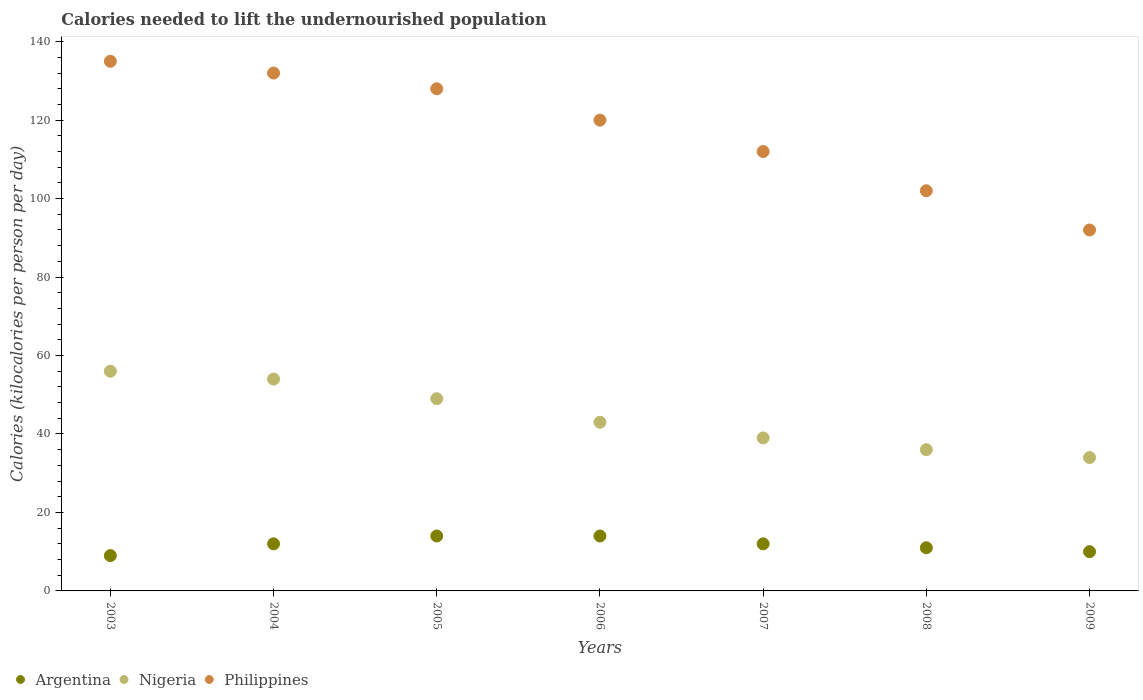What is the total calories needed to lift the undernourished population in Argentina in 2007?
Offer a terse response. 12. Across all years, what is the maximum total calories needed to lift the undernourished population in Philippines?
Provide a succinct answer. 135. Across all years, what is the minimum total calories needed to lift the undernourished population in Philippines?
Provide a succinct answer. 92. In which year was the total calories needed to lift the undernourished population in Philippines minimum?
Your response must be concise. 2009. What is the total total calories needed to lift the undernourished population in Philippines in the graph?
Your response must be concise. 821. What is the difference between the total calories needed to lift the undernourished population in Philippines in 2003 and that in 2005?
Your answer should be compact. 7. What is the difference between the total calories needed to lift the undernourished population in Philippines in 2004 and the total calories needed to lift the undernourished population in Nigeria in 2009?
Provide a short and direct response. 98. What is the average total calories needed to lift the undernourished population in Philippines per year?
Offer a terse response. 117.29. In the year 2006, what is the difference between the total calories needed to lift the undernourished population in Argentina and total calories needed to lift the undernourished population in Philippines?
Your response must be concise. -106. What is the ratio of the total calories needed to lift the undernourished population in Nigeria in 2003 to that in 2005?
Offer a terse response. 1.14. Is the total calories needed to lift the undernourished population in Argentina in 2005 less than that in 2007?
Your response must be concise. No. Is the difference between the total calories needed to lift the undernourished population in Argentina in 2006 and 2007 greater than the difference between the total calories needed to lift the undernourished population in Philippines in 2006 and 2007?
Ensure brevity in your answer.  No. What is the difference between the highest and the lowest total calories needed to lift the undernourished population in Philippines?
Give a very brief answer. 43. Is the total calories needed to lift the undernourished population in Argentina strictly greater than the total calories needed to lift the undernourished population in Nigeria over the years?
Make the answer very short. No. What is the difference between two consecutive major ticks on the Y-axis?
Keep it short and to the point. 20. How many legend labels are there?
Offer a terse response. 3. How are the legend labels stacked?
Make the answer very short. Horizontal. What is the title of the graph?
Keep it short and to the point. Calories needed to lift the undernourished population. Does "France" appear as one of the legend labels in the graph?
Make the answer very short. No. What is the label or title of the X-axis?
Your answer should be very brief. Years. What is the label or title of the Y-axis?
Your response must be concise. Calories (kilocalories per person per day). What is the Calories (kilocalories per person per day) in Philippines in 2003?
Provide a succinct answer. 135. What is the Calories (kilocalories per person per day) of Nigeria in 2004?
Your answer should be very brief. 54. What is the Calories (kilocalories per person per day) in Philippines in 2004?
Provide a succinct answer. 132. What is the Calories (kilocalories per person per day) of Philippines in 2005?
Ensure brevity in your answer.  128. What is the Calories (kilocalories per person per day) of Argentina in 2006?
Your answer should be very brief. 14. What is the Calories (kilocalories per person per day) in Nigeria in 2006?
Your answer should be very brief. 43. What is the Calories (kilocalories per person per day) in Philippines in 2006?
Provide a succinct answer. 120. What is the Calories (kilocalories per person per day) in Nigeria in 2007?
Your answer should be compact. 39. What is the Calories (kilocalories per person per day) in Philippines in 2007?
Your answer should be very brief. 112. What is the Calories (kilocalories per person per day) of Argentina in 2008?
Offer a terse response. 11. What is the Calories (kilocalories per person per day) of Nigeria in 2008?
Provide a short and direct response. 36. What is the Calories (kilocalories per person per day) in Philippines in 2008?
Ensure brevity in your answer.  102. What is the Calories (kilocalories per person per day) in Philippines in 2009?
Make the answer very short. 92. Across all years, what is the maximum Calories (kilocalories per person per day) of Argentina?
Offer a very short reply. 14. Across all years, what is the maximum Calories (kilocalories per person per day) of Nigeria?
Your answer should be very brief. 56. Across all years, what is the maximum Calories (kilocalories per person per day) of Philippines?
Offer a terse response. 135. Across all years, what is the minimum Calories (kilocalories per person per day) in Nigeria?
Make the answer very short. 34. Across all years, what is the minimum Calories (kilocalories per person per day) in Philippines?
Ensure brevity in your answer.  92. What is the total Calories (kilocalories per person per day) of Nigeria in the graph?
Make the answer very short. 311. What is the total Calories (kilocalories per person per day) of Philippines in the graph?
Offer a very short reply. 821. What is the difference between the Calories (kilocalories per person per day) of Argentina in 2003 and that in 2004?
Your response must be concise. -3. What is the difference between the Calories (kilocalories per person per day) in Philippines in 2003 and that in 2004?
Your response must be concise. 3. What is the difference between the Calories (kilocalories per person per day) in Argentina in 2003 and that in 2005?
Your response must be concise. -5. What is the difference between the Calories (kilocalories per person per day) of Philippines in 2003 and that in 2005?
Provide a short and direct response. 7. What is the difference between the Calories (kilocalories per person per day) of Philippines in 2003 and that in 2006?
Offer a terse response. 15. What is the difference between the Calories (kilocalories per person per day) of Nigeria in 2003 and that in 2008?
Your answer should be compact. 20. What is the difference between the Calories (kilocalories per person per day) of Philippines in 2003 and that in 2008?
Provide a short and direct response. 33. What is the difference between the Calories (kilocalories per person per day) of Nigeria in 2003 and that in 2009?
Offer a very short reply. 22. What is the difference between the Calories (kilocalories per person per day) of Philippines in 2003 and that in 2009?
Give a very brief answer. 43. What is the difference between the Calories (kilocalories per person per day) in Nigeria in 2004 and that in 2005?
Give a very brief answer. 5. What is the difference between the Calories (kilocalories per person per day) of Nigeria in 2004 and that in 2006?
Keep it short and to the point. 11. What is the difference between the Calories (kilocalories per person per day) of Philippines in 2004 and that in 2006?
Keep it short and to the point. 12. What is the difference between the Calories (kilocalories per person per day) of Argentina in 2004 and that in 2007?
Your answer should be very brief. 0. What is the difference between the Calories (kilocalories per person per day) of Philippines in 2004 and that in 2007?
Give a very brief answer. 20. What is the difference between the Calories (kilocalories per person per day) in Argentina in 2004 and that in 2008?
Ensure brevity in your answer.  1. What is the difference between the Calories (kilocalories per person per day) of Nigeria in 2004 and that in 2008?
Give a very brief answer. 18. What is the difference between the Calories (kilocalories per person per day) of Nigeria in 2004 and that in 2009?
Make the answer very short. 20. What is the difference between the Calories (kilocalories per person per day) in Argentina in 2005 and that in 2007?
Offer a very short reply. 2. What is the difference between the Calories (kilocalories per person per day) in Philippines in 2005 and that in 2007?
Ensure brevity in your answer.  16. What is the difference between the Calories (kilocalories per person per day) in Argentina in 2005 and that in 2009?
Your answer should be compact. 4. What is the difference between the Calories (kilocalories per person per day) of Nigeria in 2005 and that in 2009?
Your answer should be very brief. 15. What is the difference between the Calories (kilocalories per person per day) in Argentina in 2006 and that in 2007?
Your answer should be very brief. 2. What is the difference between the Calories (kilocalories per person per day) of Philippines in 2006 and that in 2008?
Provide a short and direct response. 18. What is the difference between the Calories (kilocalories per person per day) in Argentina in 2006 and that in 2009?
Offer a terse response. 4. What is the difference between the Calories (kilocalories per person per day) in Nigeria in 2006 and that in 2009?
Offer a very short reply. 9. What is the difference between the Calories (kilocalories per person per day) in Philippines in 2006 and that in 2009?
Provide a succinct answer. 28. What is the difference between the Calories (kilocalories per person per day) in Nigeria in 2007 and that in 2008?
Your answer should be compact. 3. What is the difference between the Calories (kilocalories per person per day) of Argentina in 2007 and that in 2009?
Your answer should be compact. 2. What is the difference between the Calories (kilocalories per person per day) of Nigeria in 2007 and that in 2009?
Give a very brief answer. 5. What is the difference between the Calories (kilocalories per person per day) in Argentina in 2003 and the Calories (kilocalories per person per day) in Nigeria in 2004?
Ensure brevity in your answer.  -45. What is the difference between the Calories (kilocalories per person per day) in Argentina in 2003 and the Calories (kilocalories per person per day) in Philippines in 2004?
Your answer should be compact. -123. What is the difference between the Calories (kilocalories per person per day) in Nigeria in 2003 and the Calories (kilocalories per person per day) in Philippines in 2004?
Provide a succinct answer. -76. What is the difference between the Calories (kilocalories per person per day) in Argentina in 2003 and the Calories (kilocalories per person per day) in Nigeria in 2005?
Provide a short and direct response. -40. What is the difference between the Calories (kilocalories per person per day) in Argentina in 2003 and the Calories (kilocalories per person per day) in Philippines in 2005?
Ensure brevity in your answer.  -119. What is the difference between the Calories (kilocalories per person per day) in Nigeria in 2003 and the Calories (kilocalories per person per day) in Philippines in 2005?
Ensure brevity in your answer.  -72. What is the difference between the Calories (kilocalories per person per day) of Argentina in 2003 and the Calories (kilocalories per person per day) of Nigeria in 2006?
Make the answer very short. -34. What is the difference between the Calories (kilocalories per person per day) of Argentina in 2003 and the Calories (kilocalories per person per day) of Philippines in 2006?
Provide a short and direct response. -111. What is the difference between the Calories (kilocalories per person per day) in Nigeria in 2003 and the Calories (kilocalories per person per day) in Philippines in 2006?
Offer a very short reply. -64. What is the difference between the Calories (kilocalories per person per day) in Argentina in 2003 and the Calories (kilocalories per person per day) in Nigeria in 2007?
Offer a terse response. -30. What is the difference between the Calories (kilocalories per person per day) of Argentina in 2003 and the Calories (kilocalories per person per day) of Philippines in 2007?
Your answer should be compact. -103. What is the difference between the Calories (kilocalories per person per day) in Nigeria in 2003 and the Calories (kilocalories per person per day) in Philippines in 2007?
Offer a terse response. -56. What is the difference between the Calories (kilocalories per person per day) of Argentina in 2003 and the Calories (kilocalories per person per day) of Philippines in 2008?
Keep it short and to the point. -93. What is the difference between the Calories (kilocalories per person per day) in Nigeria in 2003 and the Calories (kilocalories per person per day) in Philippines in 2008?
Provide a succinct answer. -46. What is the difference between the Calories (kilocalories per person per day) of Argentina in 2003 and the Calories (kilocalories per person per day) of Philippines in 2009?
Your response must be concise. -83. What is the difference between the Calories (kilocalories per person per day) in Nigeria in 2003 and the Calories (kilocalories per person per day) in Philippines in 2009?
Make the answer very short. -36. What is the difference between the Calories (kilocalories per person per day) in Argentina in 2004 and the Calories (kilocalories per person per day) in Nigeria in 2005?
Your response must be concise. -37. What is the difference between the Calories (kilocalories per person per day) of Argentina in 2004 and the Calories (kilocalories per person per day) of Philippines in 2005?
Keep it short and to the point. -116. What is the difference between the Calories (kilocalories per person per day) in Nigeria in 2004 and the Calories (kilocalories per person per day) in Philippines in 2005?
Your answer should be compact. -74. What is the difference between the Calories (kilocalories per person per day) of Argentina in 2004 and the Calories (kilocalories per person per day) of Nigeria in 2006?
Ensure brevity in your answer.  -31. What is the difference between the Calories (kilocalories per person per day) of Argentina in 2004 and the Calories (kilocalories per person per day) of Philippines in 2006?
Make the answer very short. -108. What is the difference between the Calories (kilocalories per person per day) in Nigeria in 2004 and the Calories (kilocalories per person per day) in Philippines in 2006?
Your answer should be very brief. -66. What is the difference between the Calories (kilocalories per person per day) in Argentina in 2004 and the Calories (kilocalories per person per day) in Nigeria in 2007?
Offer a terse response. -27. What is the difference between the Calories (kilocalories per person per day) in Argentina in 2004 and the Calories (kilocalories per person per day) in Philippines in 2007?
Your answer should be very brief. -100. What is the difference between the Calories (kilocalories per person per day) in Nigeria in 2004 and the Calories (kilocalories per person per day) in Philippines in 2007?
Keep it short and to the point. -58. What is the difference between the Calories (kilocalories per person per day) in Argentina in 2004 and the Calories (kilocalories per person per day) in Nigeria in 2008?
Offer a terse response. -24. What is the difference between the Calories (kilocalories per person per day) in Argentina in 2004 and the Calories (kilocalories per person per day) in Philippines in 2008?
Offer a terse response. -90. What is the difference between the Calories (kilocalories per person per day) of Nigeria in 2004 and the Calories (kilocalories per person per day) of Philippines in 2008?
Offer a terse response. -48. What is the difference between the Calories (kilocalories per person per day) in Argentina in 2004 and the Calories (kilocalories per person per day) in Nigeria in 2009?
Offer a very short reply. -22. What is the difference between the Calories (kilocalories per person per day) in Argentina in 2004 and the Calories (kilocalories per person per day) in Philippines in 2009?
Offer a very short reply. -80. What is the difference between the Calories (kilocalories per person per day) in Nigeria in 2004 and the Calories (kilocalories per person per day) in Philippines in 2009?
Your response must be concise. -38. What is the difference between the Calories (kilocalories per person per day) in Argentina in 2005 and the Calories (kilocalories per person per day) in Philippines in 2006?
Provide a succinct answer. -106. What is the difference between the Calories (kilocalories per person per day) of Nigeria in 2005 and the Calories (kilocalories per person per day) of Philippines in 2006?
Ensure brevity in your answer.  -71. What is the difference between the Calories (kilocalories per person per day) of Argentina in 2005 and the Calories (kilocalories per person per day) of Philippines in 2007?
Ensure brevity in your answer.  -98. What is the difference between the Calories (kilocalories per person per day) of Nigeria in 2005 and the Calories (kilocalories per person per day) of Philippines in 2007?
Give a very brief answer. -63. What is the difference between the Calories (kilocalories per person per day) in Argentina in 2005 and the Calories (kilocalories per person per day) in Nigeria in 2008?
Offer a very short reply. -22. What is the difference between the Calories (kilocalories per person per day) of Argentina in 2005 and the Calories (kilocalories per person per day) of Philippines in 2008?
Provide a short and direct response. -88. What is the difference between the Calories (kilocalories per person per day) in Nigeria in 2005 and the Calories (kilocalories per person per day) in Philippines in 2008?
Keep it short and to the point. -53. What is the difference between the Calories (kilocalories per person per day) of Argentina in 2005 and the Calories (kilocalories per person per day) of Philippines in 2009?
Keep it short and to the point. -78. What is the difference between the Calories (kilocalories per person per day) in Nigeria in 2005 and the Calories (kilocalories per person per day) in Philippines in 2009?
Offer a terse response. -43. What is the difference between the Calories (kilocalories per person per day) in Argentina in 2006 and the Calories (kilocalories per person per day) in Nigeria in 2007?
Provide a succinct answer. -25. What is the difference between the Calories (kilocalories per person per day) of Argentina in 2006 and the Calories (kilocalories per person per day) of Philippines in 2007?
Provide a succinct answer. -98. What is the difference between the Calories (kilocalories per person per day) of Nigeria in 2006 and the Calories (kilocalories per person per day) of Philippines in 2007?
Provide a short and direct response. -69. What is the difference between the Calories (kilocalories per person per day) of Argentina in 2006 and the Calories (kilocalories per person per day) of Nigeria in 2008?
Your answer should be compact. -22. What is the difference between the Calories (kilocalories per person per day) of Argentina in 2006 and the Calories (kilocalories per person per day) of Philippines in 2008?
Ensure brevity in your answer.  -88. What is the difference between the Calories (kilocalories per person per day) in Nigeria in 2006 and the Calories (kilocalories per person per day) in Philippines in 2008?
Your answer should be compact. -59. What is the difference between the Calories (kilocalories per person per day) in Argentina in 2006 and the Calories (kilocalories per person per day) in Nigeria in 2009?
Keep it short and to the point. -20. What is the difference between the Calories (kilocalories per person per day) in Argentina in 2006 and the Calories (kilocalories per person per day) in Philippines in 2009?
Provide a short and direct response. -78. What is the difference between the Calories (kilocalories per person per day) of Nigeria in 2006 and the Calories (kilocalories per person per day) of Philippines in 2009?
Your response must be concise. -49. What is the difference between the Calories (kilocalories per person per day) of Argentina in 2007 and the Calories (kilocalories per person per day) of Nigeria in 2008?
Give a very brief answer. -24. What is the difference between the Calories (kilocalories per person per day) of Argentina in 2007 and the Calories (kilocalories per person per day) of Philippines in 2008?
Keep it short and to the point. -90. What is the difference between the Calories (kilocalories per person per day) of Nigeria in 2007 and the Calories (kilocalories per person per day) of Philippines in 2008?
Make the answer very short. -63. What is the difference between the Calories (kilocalories per person per day) in Argentina in 2007 and the Calories (kilocalories per person per day) in Nigeria in 2009?
Offer a terse response. -22. What is the difference between the Calories (kilocalories per person per day) in Argentina in 2007 and the Calories (kilocalories per person per day) in Philippines in 2009?
Keep it short and to the point. -80. What is the difference between the Calories (kilocalories per person per day) of Nigeria in 2007 and the Calories (kilocalories per person per day) of Philippines in 2009?
Make the answer very short. -53. What is the difference between the Calories (kilocalories per person per day) in Argentina in 2008 and the Calories (kilocalories per person per day) in Philippines in 2009?
Your response must be concise. -81. What is the difference between the Calories (kilocalories per person per day) of Nigeria in 2008 and the Calories (kilocalories per person per day) of Philippines in 2009?
Provide a succinct answer. -56. What is the average Calories (kilocalories per person per day) of Argentina per year?
Keep it short and to the point. 11.71. What is the average Calories (kilocalories per person per day) of Nigeria per year?
Provide a succinct answer. 44.43. What is the average Calories (kilocalories per person per day) in Philippines per year?
Your answer should be very brief. 117.29. In the year 2003, what is the difference between the Calories (kilocalories per person per day) of Argentina and Calories (kilocalories per person per day) of Nigeria?
Provide a succinct answer. -47. In the year 2003, what is the difference between the Calories (kilocalories per person per day) of Argentina and Calories (kilocalories per person per day) of Philippines?
Your answer should be compact. -126. In the year 2003, what is the difference between the Calories (kilocalories per person per day) of Nigeria and Calories (kilocalories per person per day) of Philippines?
Your response must be concise. -79. In the year 2004, what is the difference between the Calories (kilocalories per person per day) in Argentina and Calories (kilocalories per person per day) in Nigeria?
Your answer should be very brief. -42. In the year 2004, what is the difference between the Calories (kilocalories per person per day) of Argentina and Calories (kilocalories per person per day) of Philippines?
Provide a succinct answer. -120. In the year 2004, what is the difference between the Calories (kilocalories per person per day) in Nigeria and Calories (kilocalories per person per day) in Philippines?
Provide a short and direct response. -78. In the year 2005, what is the difference between the Calories (kilocalories per person per day) in Argentina and Calories (kilocalories per person per day) in Nigeria?
Offer a terse response. -35. In the year 2005, what is the difference between the Calories (kilocalories per person per day) of Argentina and Calories (kilocalories per person per day) of Philippines?
Make the answer very short. -114. In the year 2005, what is the difference between the Calories (kilocalories per person per day) of Nigeria and Calories (kilocalories per person per day) of Philippines?
Your answer should be very brief. -79. In the year 2006, what is the difference between the Calories (kilocalories per person per day) of Argentina and Calories (kilocalories per person per day) of Nigeria?
Your response must be concise. -29. In the year 2006, what is the difference between the Calories (kilocalories per person per day) of Argentina and Calories (kilocalories per person per day) of Philippines?
Give a very brief answer. -106. In the year 2006, what is the difference between the Calories (kilocalories per person per day) in Nigeria and Calories (kilocalories per person per day) in Philippines?
Provide a succinct answer. -77. In the year 2007, what is the difference between the Calories (kilocalories per person per day) of Argentina and Calories (kilocalories per person per day) of Philippines?
Your answer should be compact. -100. In the year 2007, what is the difference between the Calories (kilocalories per person per day) in Nigeria and Calories (kilocalories per person per day) in Philippines?
Keep it short and to the point. -73. In the year 2008, what is the difference between the Calories (kilocalories per person per day) in Argentina and Calories (kilocalories per person per day) in Nigeria?
Provide a short and direct response. -25. In the year 2008, what is the difference between the Calories (kilocalories per person per day) in Argentina and Calories (kilocalories per person per day) in Philippines?
Your response must be concise. -91. In the year 2008, what is the difference between the Calories (kilocalories per person per day) in Nigeria and Calories (kilocalories per person per day) in Philippines?
Offer a very short reply. -66. In the year 2009, what is the difference between the Calories (kilocalories per person per day) in Argentina and Calories (kilocalories per person per day) in Philippines?
Your answer should be very brief. -82. In the year 2009, what is the difference between the Calories (kilocalories per person per day) in Nigeria and Calories (kilocalories per person per day) in Philippines?
Keep it short and to the point. -58. What is the ratio of the Calories (kilocalories per person per day) in Nigeria in 2003 to that in 2004?
Make the answer very short. 1.04. What is the ratio of the Calories (kilocalories per person per day) of Philippines in 2003 to that in 2004?
Ensure brevity in your answer.  1.02. What is the ratio of the Calories (kilocalories per person per day) of Argentina in 2003 to that in 2005?
Your answer should be very brief. 0.64. What is the ratio of the Calories (kilocalories per person per day) in Philippines in 2003 to that in 2005?
Provide a short and direct response. 1.05. What is the ratio of the Calories (kilocalories per person per day) in Argentina in 2003 to that in 2006?
Ensure brevity in your answer.  0.64. What is the ratio of the Calories (kilocalories per person per day) in Nigeria in 2003 to that in 2006?
Your response must be concise. 1.3. What is the ratio of the Calories (kilocalories per person per day) of Nigeria in 2003 to that in 2007?
Make the answer very short. 1.44. What is the ratio of the Calories (kilocalories per person per day) of Philippines in 2003 to that in 2007?
Offer a very short reply. 1.21. What is the ratio of the Calories (kilocalories per person per day) in Argentina in 2003 to that in 2008?
Your answer should be very brief. 0.82. What is the ratio of the Calories (kilocalories per person per day) in Nigeria in 2003 to that in 2008?
Make the answer very short. 1.56. What is the ratio of the Calories (kilocalories per person per day) in Philippines in 2003 to that in 2008?
Provide a short and direct response. 1.32. What is the ratio of the Calories (kilocalories per person per day) of Nigeria in 2003 to that in 2009?
Give a very brief answer. 1.65. What is the ratio of the Calories (kilocalories per person per day) in Philippines in 2003 to that in 2009?
Offer a terse response. 1.47. What is the ratio of the Calories (kilocalories per person per day) in Argentina in 2004 to that in 2005?
Provide a short and direct response. 0.86. What is the ratio of the Calories (kilocalories per person per day) in Nigeria in 2004 to that in 2005?
Offer a very short reply. 1.1. What is the ratio of the Calories (kilocalories per person per day) in Philippines in 2004 to that in 2005?
Your response must be concise. 1.03. What is the ratio of the Calories (kilocalories per person per day) in Argentina in 2004 to that in 2006?
Your answer should be very brief. 0.86. What is the ratio of the Calories (kilocalories per person per day) of Nigeria in 2004 to that in 2006?
Provide a succinct answer. 1.26. What is the ratio of the Calories (kilocalories per person per day) of Argentina in 2004 to that in 2007?
Your answer should be compact. 1. What is the ratio of the Calories (kilocalories per person per day) in Nigeria in 2004 to that in 2007?
Ensure brevity in your answer.  1.38. What is the ratio of the Calories (kilocalories per person per day) in Philippines in 2004 to that in 2007?
Your response must be concise. 1.18. What is the ratio of the Calories (kilocalories per person per day) in Argentina in 2004 to that in 2008?
Your answer should be compact. 1.09. What is the ratio of the Calories (kilocalories per person per day) in Philippines in 2004 to that in 2008?
Make the answer very short. 1.29. What is the ratio of the Calories (kilocalories per person per day) in Argentina in 2004 to that in 2009?
Your answer should be very brief. 1.2. What is the ratio of the Calories (kilocalories per person per day) in Nigeria in 2004 to that in 2009?
Offer a terse response. 1.59. What is the ratio of the Calories (kilocalories per person per day) of Philippines in 2004 to that in 2009?
Your response must be concise. 1.43. What is the ratio of the Calories (kilocalories per person per day) in Argentina in 2005 to that in 2006?
Make the answer very short. 1. What is the ratio of the Calories (kilocalories per person per day) in Nigeria in 2005 to that in 2006?
Your answer should be compact. 1.14. What is the ratio of the Calories (kilocalories per person per day) of Philippines in 2005 to that in 2006?
Keep it short and to the point. 1.07. What is the ratio of the Calories (kilocalories per person per day) of Nigeria in 2005 to that in 2007?
Ensure brevity in your answer.  1.26. What is the ratio of the Calories (kilocalories per person per day) in Argentina in 2005 to that in 2008?
Give a very brief answer. 1.27. What is the ratio of the Calories (kilocalories per person per day) of Nigeria in 2005 to that in 2008?
Your answer should be very brief. 1.36. What is the ratio of the Calories (kilocalories per person per day) in Philippines in 2005 to that in 2008?
Keep it short and to the point. 1.25. What is the ratio of the Calories (kilocalories per person per day) of Nigeria in 2005 to that in 2009?
Offer a terse response. 1.44. What is the ratio of the Calories (kilocalories per person per day) of Philippines in 2005 to that in 2009?
Give a very brief answer. 1.39. What is the ratio of the Calories (kilocalories per person per day) in Nigeria in 2006 to that in 2007?
Your answer should be compact. 1.1. What is the ratio of the Calories (kilocalories per person per day) of Philippines in 2006 to that in 2007?
Provide a succinct answer. 1.07. What is the ratio of the Calories (kilocalories per person per day) in Argentina in 2006 to that in 2008?
Offer a very short reply. 1.27. What is the ratio of the Calories (kilocalories per person per day) of Nigeria in 2006 to that in 2008?
Your response must be concise. 1.19. What is the ratio of the Calories (kilocalories per person per day) of Philippines in 2006 to that in 2008?
Ensure brevity in your answer.  1.18. What is the ratio of the Calories (kilocalories per person per day) in Nigeria in 2006 to that in 2009?
Your answer should be very brief. 1.26. What is the ratio of the Calories (kilocalories per person per day) in Philippines in 2006 to that in 2009?
Make the answer very short. 1.3. What is the ratio of the Calories (kilocalories per person per day) of Philippines in 2007 to that in 2008?
Your answer should be compact. 1.1. What is the ratio of the Calories (kilocalories per person per day) in Argentina in 2007 to that in 2009?
Offer a very short reply. 1.2. What is the ratio of the Calories (kilocalories per person per day) in Nigeria in 2007 to that in 2009?
Provide a short and direct response. 1.15. What is the ratio of the Calories (kilocalories per person per day) of Philippines in 2007 to that in 2009?
Provide a short and direct response. 1.22. What is the ratio of the Calories (kilocalories per person per day) of Nigeria in 2008 to that in 2009?
Your answer should be very brief. 1.06. What is the ratio of the Calories (kilocalories per person per day) in Philippines in 2008 to that in 2009?
Your answer should be very brief. 1.11. What is the difference between the highest and the second highest Calories (kilocalories per person per day) in Argentina?
Offer a terse response. 0. What is the difference between the highest and the second highest Calories (kilocalories per person per day) in Nigeria?
Offer a very short reply. 2. 